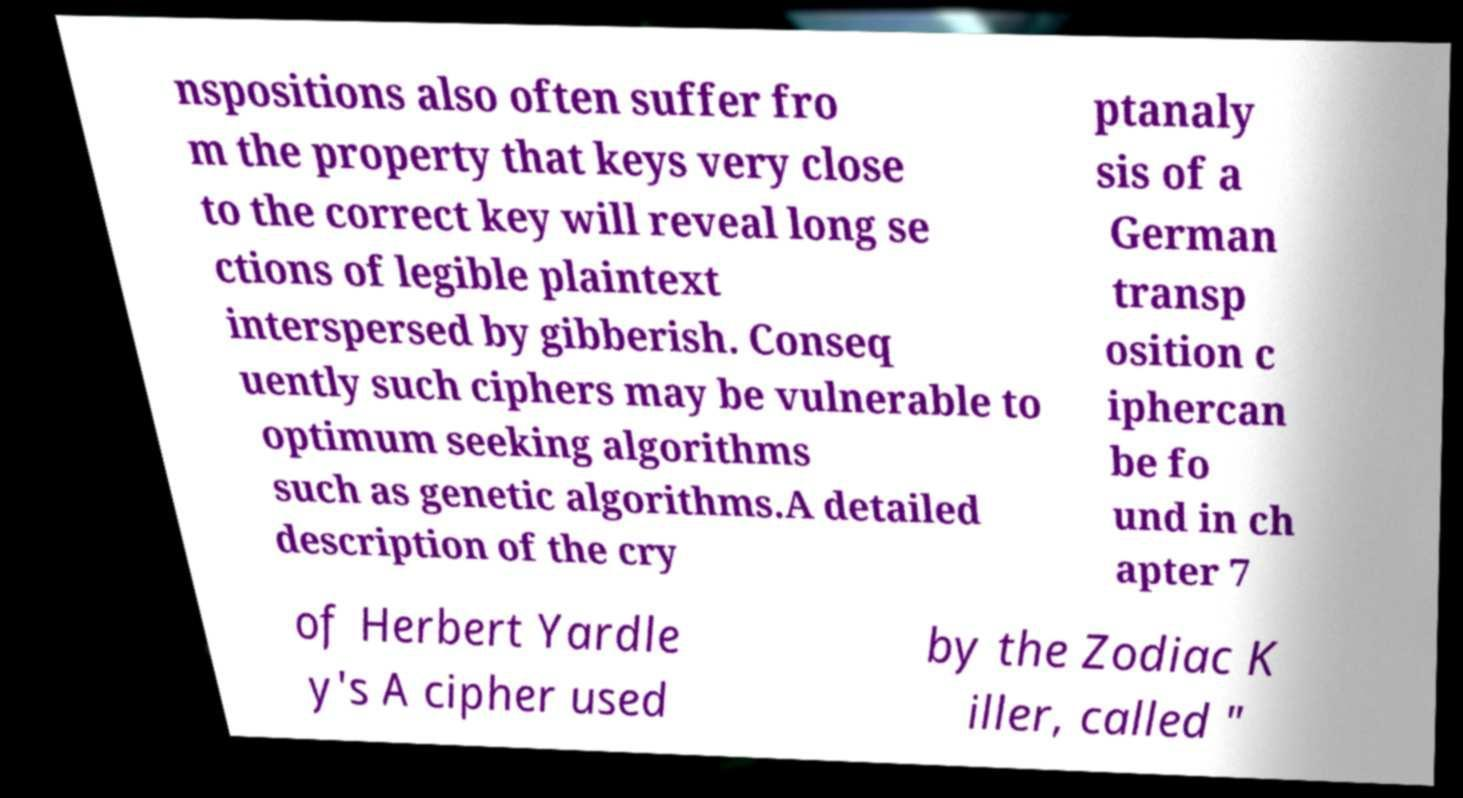For documentation purposes, I need the text within this image transcribed. Could you provide that? nspositions also often suffer fro m the property that keys very close to the correct key will reveal long se ctions of legible plaintext interspersed by gibberish. Conseq uently such ciphers may be vulnerable to optimum seeking algorithms such as genetic algorithms.A detailed description of the cry ptanaly sis of a German transp osition c iphercan be fo und in ch apter 7 of Herbert Yardle y's A cipher used by the Zodiac K iller, called " 